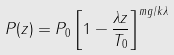<formula> <loc_0><loc_0><loc_500><loc_500>P ( z ) = P _ { 0 } \left [ 1 - \frac { \lambda z } { T _ { 0 } } \right ] ^ { m g / k \lambda }</formula> 